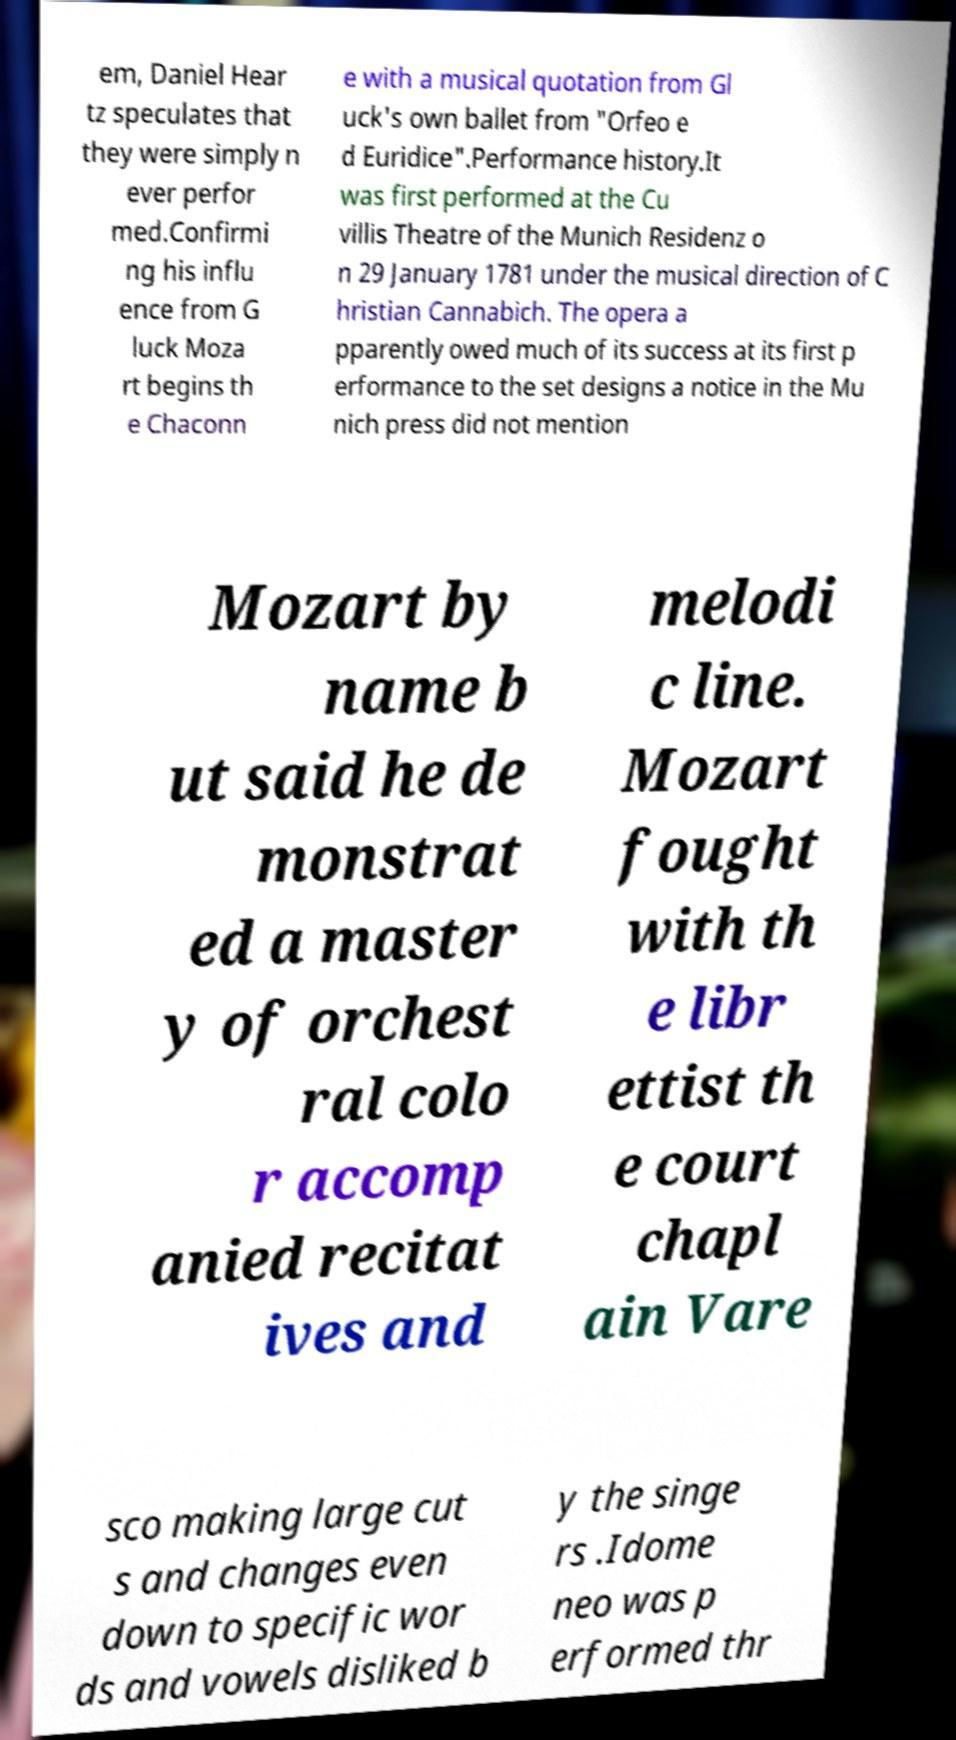Can you read and provide the text displayed in the image?This photo seems to have some interesting text. Can you extract and type it out for me? em, Daniel Hear tz speculates that they were simply n ever perfor med.Confirmi ng his influ ence from G luck Moza rt begins th e Chaconn e with a musical quotation from Gl uck's own ballet from "Orfeo e d Euridice".Performance history.It was first performed at the Cu villis Theatre of the Munich Residenz o n 29 January 1781 under the musical direction of C hristian Cannabich. The opera a pparently owed much of its success at its first p erformance to the set designs a notice in the Mu nich press did not mention Mozart by name b ut said he de monstrat ed a master y of orchest ral colo r accomp anied recitat ives and melodi c line. Mozart fought with th e libr ettist th e court chapl ain Vare sco making large cut s and changes even down to specific wor ds and vowels disliked b y the singe rs .Idome neo was p erformed thr 